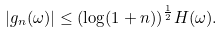Convert formula to latex. <formula><loc_0><loc_0><loc_500><loc_500>| g _ { n } ( \omega ) | \leq ( \log ( 1 + n ) ) ^ { \frac { 1 } { 2 } } H ( \omega ) .</formula> 